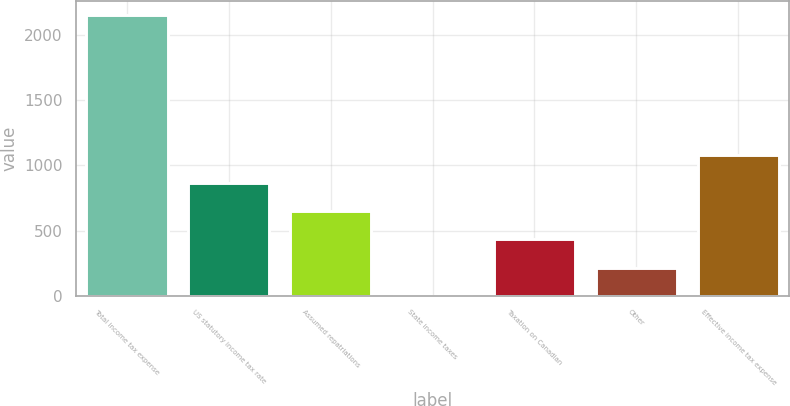<chart> <loc_0><loc_0><loc_500><loc_500><bar_chart><fcel>Total income tax expense<fcel>US statutory income tax rate<fcel>Assumed repatriations<fcel>State income taxes<fcel>Taxation on Canadian<fcel>Other<fcel>Effective income tax expense<nl><fcel>2156<fcel>863<fcel>647.5<fcel>1<fcel>432<fcel>216.5<fcel>1078.5<nl></chart> 